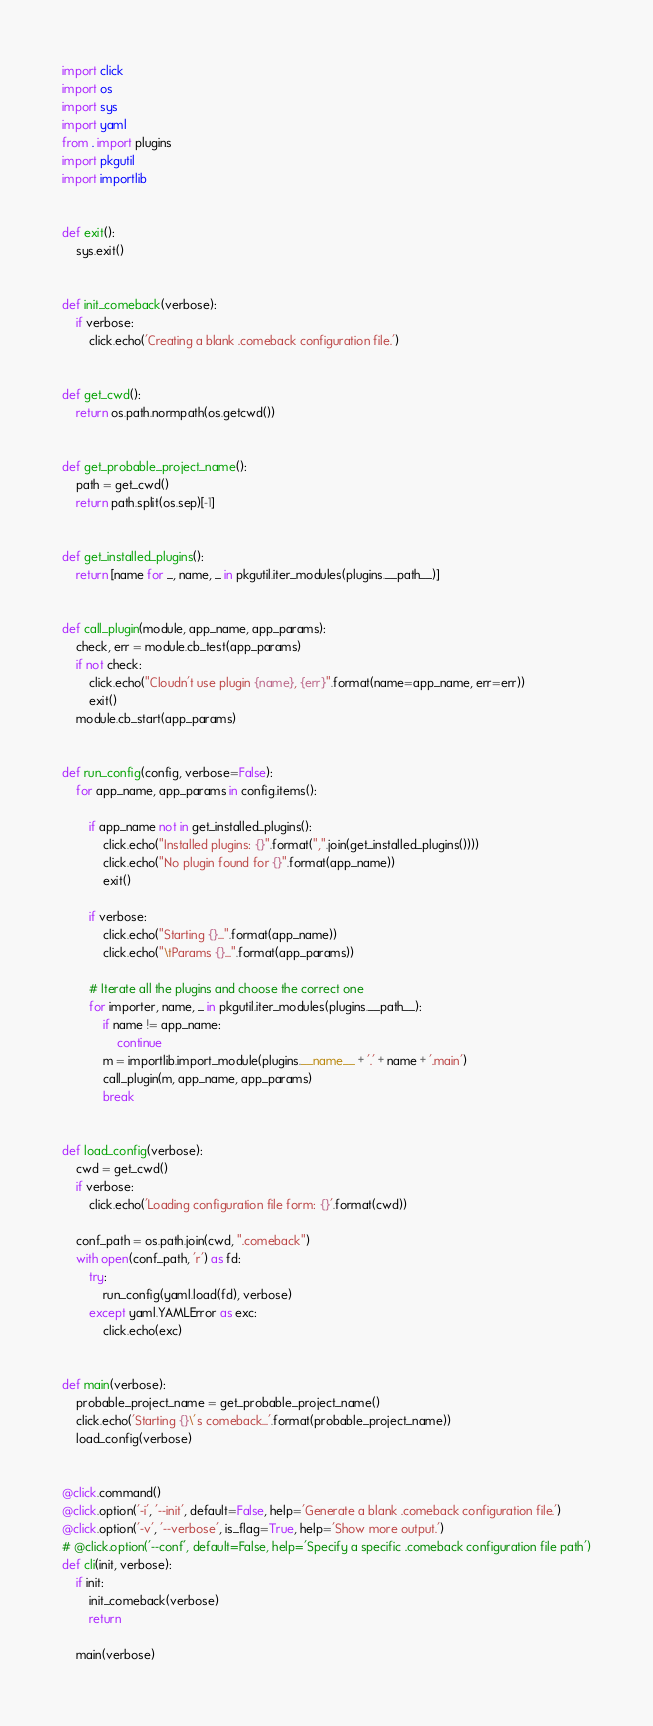<code> <loc_0><loc_0><loc_500><loc_500><_Python_>import click
import os
import sys
import yaml
from . import plugins
import pkgutil
import importlib


def exit():
    sys.exit()


def init_comeback(verbose):
    if verbose:
        click.echo('Creating a blank .comeback configuration file.')


def get_cwd():
    return os.path.normpath(os.getcwd())


def get_probable_project_name():
    path = get_cwd()
    return path.split(os.sep)[-1]


def get_installed_plugins():
    return [name for _, name, _ in pkgutil.iter_modules(plugins.__path__)]


def call_plugin(module, app_name, app_params):
    check, err = module.cb_test(app_params)
    if not check:
        click.echo("Cloudn't use plugin {name}, {err}".format(name=app_name, err=err))
        exit()
    module.cb_start(app_params)


def run_config(config, verbose=False):
    for app_name, app_params in config.items():

        if app_name not in get_installed_plugins():
            click.echo("Installed plugins: {}".format(",".join(get_installed_plugins())))
            click.echo("No plugin found for {}".format(app_name))
            exit()

        if verbose:
            click.echo("Starting {}...".format(app_name))
            click.echo("\tParams {}...".format(app_params))

        # Iterate all the plugins and choose the correct one
        for importer, name, _ in pkgutil.iter_modules(plugins.__path__):
            if name != app_name:
                continue
            m = importlib.import_module(plugins.__name__ + '.' + name + '.main')
            call_plugin(m, app_name, app_params)
            break


def load_config(verbose):
    cwd = get_cwd()
    if verbose:
        click.echo('Loading configuration file form: {}'.format(cwd))

    conf_path = os.path.join(cwd, ".comeback")
    with open(conf_path, 'r') as fd:
        try:
            run_config(yaml.load(fd), verbose)
        except yaml.YAMLError as exc:
            click.echo(exc)


def main(verbose):
    probable_project_name = get_probable_project_name()
    click.echo('Starting {}\'s comeback...'.format(probable_project_name))
    load_config(verbose)


@click.command()
@click.option('-i', '--init', default=False, help='Generate a blank .comeback configuration file.')
@click.option('-v', '--verbose', is_flag=True, help='Show more output.')
# @click.option('--conf', default=False, help='Specify a specific .comeback configuration file path')
def cli(init, verbose):
    if init:
        init_comeback(verbose)
        return

    main(verbose)
</code> 